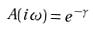Convert formula to latex. <formula><loc_0><loc_0><loc_500><loc_500>A ( i \omega ) = e ^ { - \gamma }</formula> 